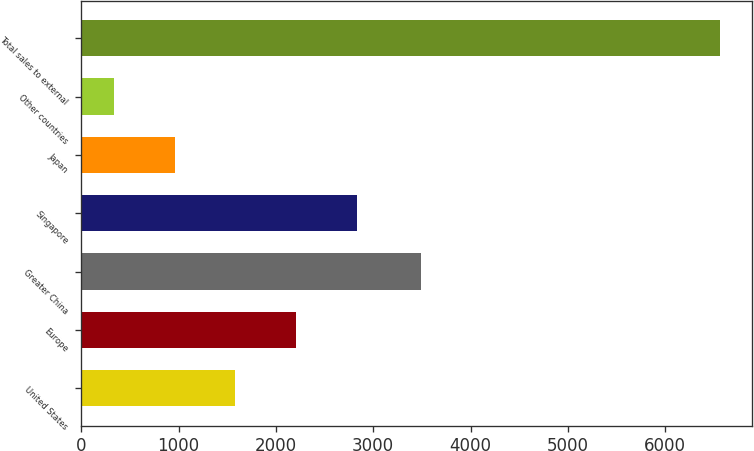Convert chart to OTSL. <chart><loc_0><loc_0><loc_500><loc_500><bar_chart><fcel>United States<fcel>Europe<fcel>Greater China<fcel>Singapore<fcel>Japan<fcel>Other countries<fcel>Total sales to external<nl><fcel>1584.8<fcel>2207.7<fcel>3493<fcel>2830.6<fcel>961.9<fcel>339<fcel>6568<nl></chart> 